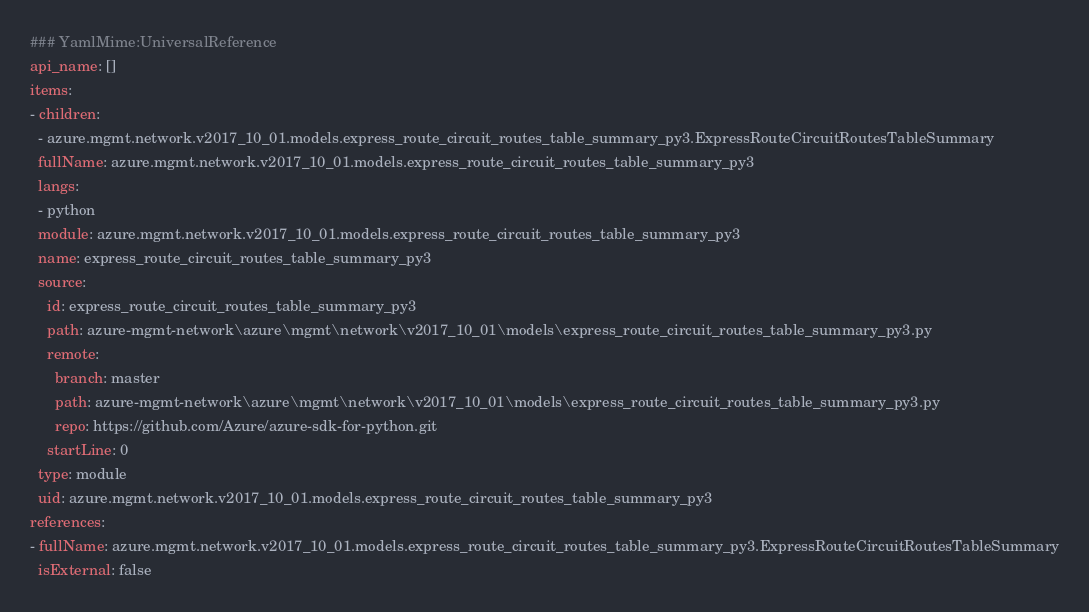<code> <loc_0><loc_0><loc_500><loc_500><_YAML_>### YamlMime:UniversalReference
api_name: []
items:
- children:
  - azure.mgmt.network.v2017_10_01.models.express_route_circuit_routes_table_summary_py3.ExpressRouteCircuitRoutesTableSummary
  fullName: azure.mgmt.network.v2017_10_01.models.express_route_circuit_routes_table_summary_py3
  langs:
  - python
  module: azure.mgmt.network.v2017_10_01.models.express_route_circuit_routes_table_summary_py3
  name: express_route_circuit_routes_table_summary_py3
  source:
    id: express_route_circuit_routes_table_summary_py3
    path: azure-mgmt-network\azure\mgmt\network\v2017_10_01\models\express_route_circuit_routes_table_summary_py3.py
    remote:
      branch: master
      path: azure-mgmt-network\azure\mgmt\network\v2017_10_01\models\express_route_circuit_routes_table_summary_py3.py
      repo: https://github.com/Azure/azure-sdk-for-python.git
    startLine: 0
  type: module
  uid: azure.mgmt.network.v2017_10_01.models.express_route_circuit_routes_table_summary_py3
references:
- fullName: azure.mgmt.network.v2017_10_01.models.express_route_circuit_routes_table_summary_py3.ExpressRouteCircuitRoutesTableSummary
  isExternal: false</code> 